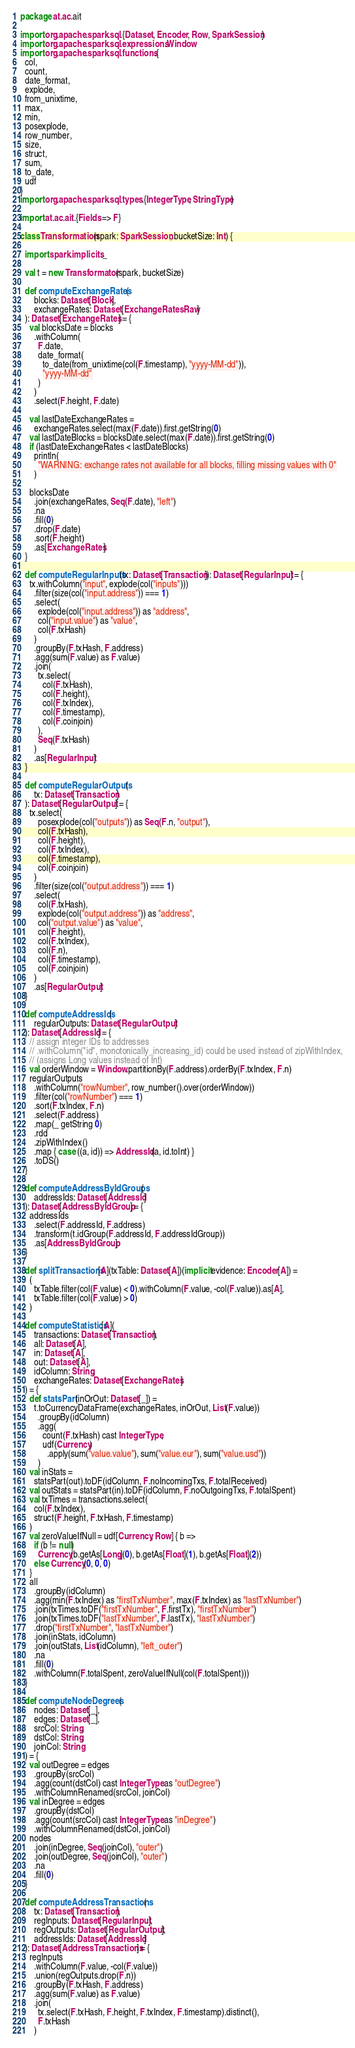<code> <loc_0><loc_0><loc_500><loc_500><_Scala_>package at.ac.ait

import org.apache.spark.sql.{Dataset, Encoder, Row, SparkSession}
import org.apache.spark.sql.expressions.Window
import org.apache.spark.sql.functions.{
  col,
  count,
  date_format,
  explode,
  from_unixtime,
  max,
  min,
  posexplode,
  row_number,
  size,
  struct,
  sum,
  to_date,
  udf
}
import org.apache.spark.sql.types.{IntegerType, StringType}

import at.ac.ait.{Fields => F}

class Transformation(spark: SparkSession, bucketSize: Int) {

  import spark.implicits._

  val t = new Transformator(spark, bucketSize)

  def computeExchangeRates(
      blocks: Dataset[Block],
      exchangeRates: Dataset[ExchangeRatesRaw]
  ): Dataset[ExchangeRates] = {
    val blocksDate = blocks
      .withColumn(
        F.date,
        date_format(
          to_date(from_unixtime(col(F.timestamp), "yyyy-MM-dd")),
          "yyyy-MM-dd"
        )
      )
      .select(F.height, F.date)

    val lastDateExchangeRates =
      exchangeRates.select(max(F.date)).first.getString(0)
    val lastDateBlocks = blocksDate.select(max(F.date)).first.getString(0)
    if (lastDateExchangeRates < lastDateBlocks)
      println(
        "WARNING: exchange rates not available for all blocks, filling missing values with 0"
      )

    blocksDate
      .join(exchangeRates, Seq(F.date), "left")
      .na
      .fill(0)
      .drop(F.date)
      .sort(F.height)
      .as[ExchangeRates]
  }

  def computeRegularInputs(tx: Dataset[Transaction]): Dataset[RegularInput] = {
    tx.withColumn("input", explode(col("inputs")))
      .filter(size(col("input.address")) === 1)
      .select(
        explode(col("input.address")) as "address",
        col("input.value") as "value",
        col(F.txHash)
      )
      .groupBy(F.txHash, F.address)
      .agg(sum(F.value) as F.value)
      .join(
        tx.select(
          col(F.txHash),
          col(F.height),
          col(F.txIndex),
          col(F.timestamp),
          col(F.coinjoin)
        ),
        Seq(F.txHash)
      )
      .as[RegularInput]
  }

  def computeRegularOutputs(
      tx: Dataset[Transaction]
  ): Dataset[RegularOutput] = {
    tx.select(
        posexplode(col("outputs")) as Seq(F.n, "output"),
        col(F.txHash),
        col(F.height),
        col(F.txIndex),
        col(F.timestamp),
        col(F.coinjoin)
      )
      .filter(size(col("output.address")) === 1)
      .select(
        col(F.txHash),
        explode(col("output.address")) as "address",
        col("output.value") as "value",
        col(F.height),
        col(F.txIndex),
        col(F.n),
        col(F.timestamp),
        col(F.coinjoin)
      )
      .as[RegularOutput]
  }

  def computeAddressIds(
      regularOutputs: Dataset[RegularOutput]
  ): Dataset[AddressId] = {
    // assign integer IDs to addresses
    // .withColumn("id", monotonically_increasing_id) could be used instead of zipWithIndex,
    // (assigns Long values instead of Int)
    val orderWindow = Window.partitionBy(F.address).orderBy(F.txIndex, F.n)
    regularOutputs
      .withColumn("rowNumber", row_number().over(orderWindow))
      .filter(col("rowNumber") === 1)
      .sort(F.txIndex, F.n)
      .select(F.address)
      .map(_ getString 0)
      .rdd
      .zipWithIndex()
      .map { case ((a, id)) => AddressId(a, id.toInt) }
      .toDS()
  }

  def computeAddressByIdGroups(
      addressIds: Dataset[AddressId]
  ): Dataset[AddressByIdGroup] = {
    addressIds
      .select(F.addressId, F.address)
      .transform(t.idGroup(F.addressId, F.addressIdGroup))
      .as[AddressByIdGroup]
  }

  def splitTransactions[A](txTable: Dataset[A])(implicit evidence: Encoder[A]) =
    (
      txTable.filter(col(F.value) < 0).withColumn(F.value, -col(F.value)).as[A],
      txTable.filter(col(F.value) > 0)
    )

  def computeStatistics[A](
      transactions: Dataset[Transaction],
      all: Dataset[A],
      in: Dataset[A],
      out: Dataset[A],
      idColumn: String,
      exchangeRates: Dataset[ExchangeRates]
  ) = {
    def statsPart(inOrOut: Dataset[_]) =
      t.toCurrencyDataFrame(exchangeRates, inOrOut, List(F.value))
        .groupBy(idColumn)
        .agg(
          count(F.txHash) cast IntegerType,
          udf(Currency)
            .apply(sum("value.value"), sum("value.eur"), sum("value.usd"))
        )
    val inStats =
      statsPart(out).toDF(idColumn, F.noIncomingTxs, F.totalReceived)
    val outStats = statsPart(in).toDF(idColumn, F.noOutgoingTxs, F.totalSpent)
    val txTimes = transactions.select(
      col(F.txIndex),
      struct(F.height, F.txHash, F.timestamp)
    )
    val zeroValueIfNull = udf[Currency, Row] { b =>
      if (b != null)
        Currency(b.getAs[Long](0), b.getAs[Float](1), b.getAs[Float](2))
      else Currency(0, 0, 0)
    }
    all
      .groupBy(idColumn)
      .agg(min(F.txIndex) as "firstTxNumber", max(F.txIndex) as "lastTxNumber")
      .join(txTimes.toDF("firstTxNumber", F.firstTx), "firstTxNumber")
      .join(txTimes.toDF("lastTxNumber", F.lastTx), "lastTxNumber")
      .drop("firstTxNumber", "lastTxNumber")
      .join(inStats, idColumn)
      .join(outStats, List(idColumn), "left_outer")
      .na
      .fill(0)
      .withColumn(F.totalSpent, zeroValueIfNull(col(F.totalSpent)))
  }

  def computeNodeDegrees(
      nodes: Dataset[_],
      edges: Dataset[_],
      srcCol: String,
      dstCol: String,
      joinCol: String
  ) = {
    val outDegree = edges
      .groupBy(srcCol)
      .agg(count(dstCol) cast IntegerType as "outDegree")
      .withColumnRenamed(srcCol, joinCol)
    val inDegree = edges
      .groupBy(dstCol)
      .agg(count(srcCol) cast IntegerType as "inDegree")
      .withColumnRenamed(dstCol, joinCol)
    nodes
      .join(inDegree, Seq(joinCol), "outer")
      .join(outDegree, Seq(joinCol), "outer")
      .na
      .fill(0)
  }

  def computeAddressTransactions(
      tx: Dataset[Transaction],
      regInputs: Dataset[RegularInput],
      regOutputs: Dataset[RegularOutput],
      addressIds: Dataset[AddressId]
  ): Dataset[AddressTransactions] = {
    regInputs
      .withColumn(F.value, -col(F.value))
      .union(regOutputs.drop(F.n))
      .groupBy(F.txHash, F.address)
      .agg(sum(F.value) as F.value)
      .join(
        tx.select(F.txHash, F.height, F.txIndex, F.timestamp).distinct(),
        F.txHash
      )</code> 